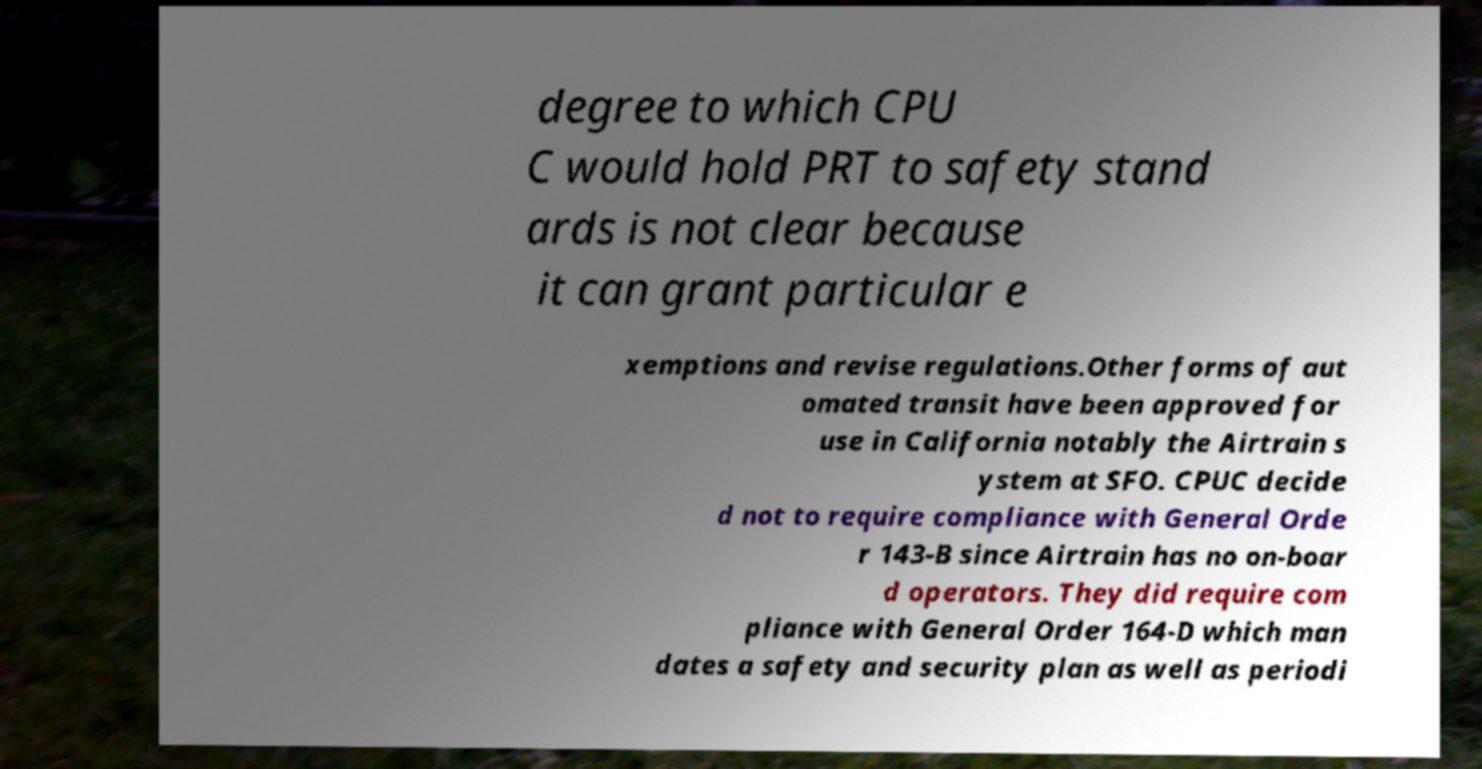Could you assist in decoding the text presented in this image and type it out clearly? degree to which CPU C would hold PRT to safety stand ards is not clear because it can grant particular e xemptions and revise regulations.Other forms of aut omated transit have been approved for use in California notably the Airtrain s ystem at SFO. CPUC decide d not to require compliance with General Orde r 143-B since Airtrain has no on-boar d operators. They did require com pliance with General Order 164-D which man dates a safety and security plan as well as periodi 